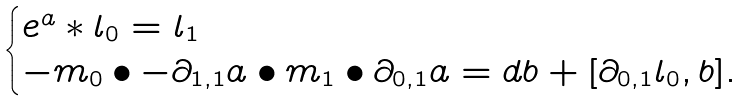Convert formula to latex. <formula><loc_0><loc_0><loc_500><loc_500>\begin{cases} e ^ { a } * l _ { 0 } = l _ { 1 } \\ - m _ { 0 } \bullet - \partial _ { 1 , 1 } a \bullet m _ { 1 } \bullet \partial _ { 0 , 1 } a = d b + [ \partial _ { 0 , 1 } l _ { 0 } , b ] . \end{cases}</formula> 